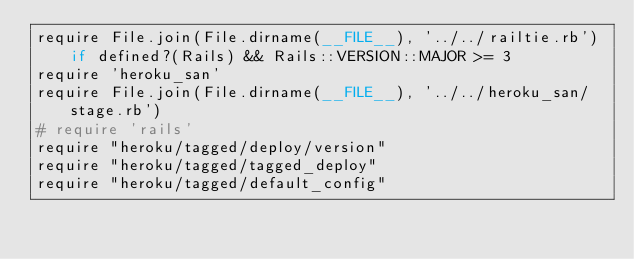Convert code to text. <code><loc_0><loc_0><loc_500><loc_500><_Ruby_>require File.join(File.dirname(__FILE__), '../../railtie.rb') if defined?(Rails) && Rails::VERSION::MAJOR >= 3
require 'heroku_san'
require File.join(File.dirname(__FILE__), '../../heroku_san/stage.rb')
# require 'rails'
require "heroku/tagged/deploy/version"
require "heroku/tagged/tagged_deploy"
require "heroku/tagged/default_config"
</code> 